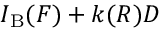<formula> <loc_0><loc_0><loc_500><loc_500>I _ { B } ( F ) + k ( R ) D</formula> 